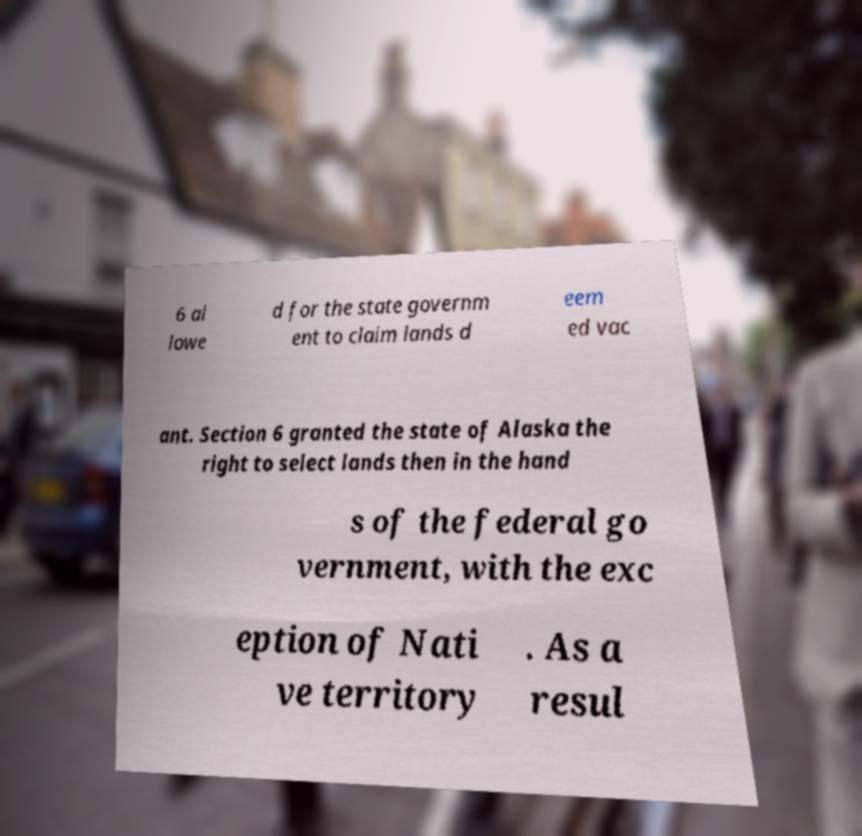Can you read and provide the text displayed in the image?This photo seems to have some interesting text. Can you extract and type it out for me? 6 al lowe d for the state governm ent to claim lands d eem ed vac ant. Section 6 granted the state of Alaska the right to select lands then in the hand s of the federal go vernment, with the exc eption of Nati ve territory . As a resul 